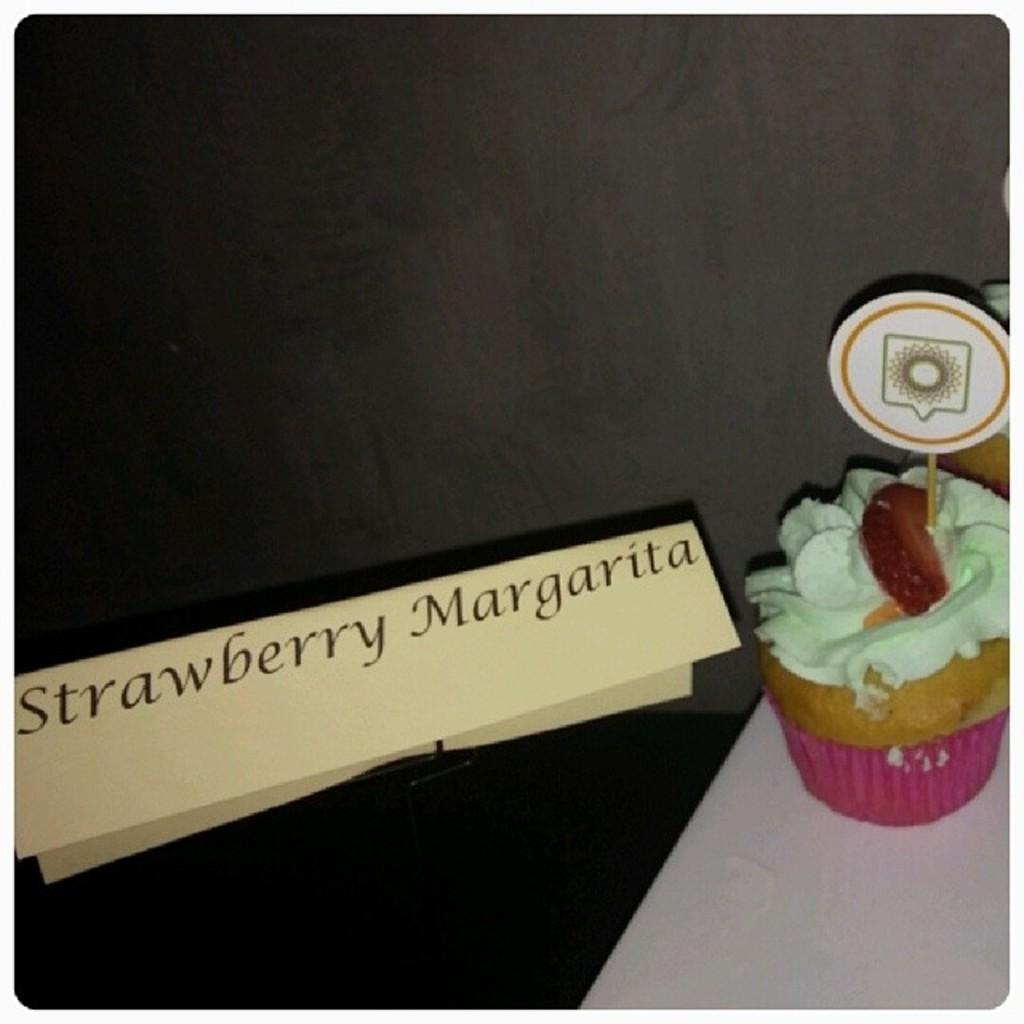What is the main object in the image? There is a name board in the image. What type of food can be seen on a white surface? There are cupcakes with cream on a white surface. What color is the background of the image? The background of the image is black. How many boys are playing with toothpaste in the image? There are no boys or toothpaste present in the image. What type of prose is written on the name board? There is no prose visible on the name board in the image. 